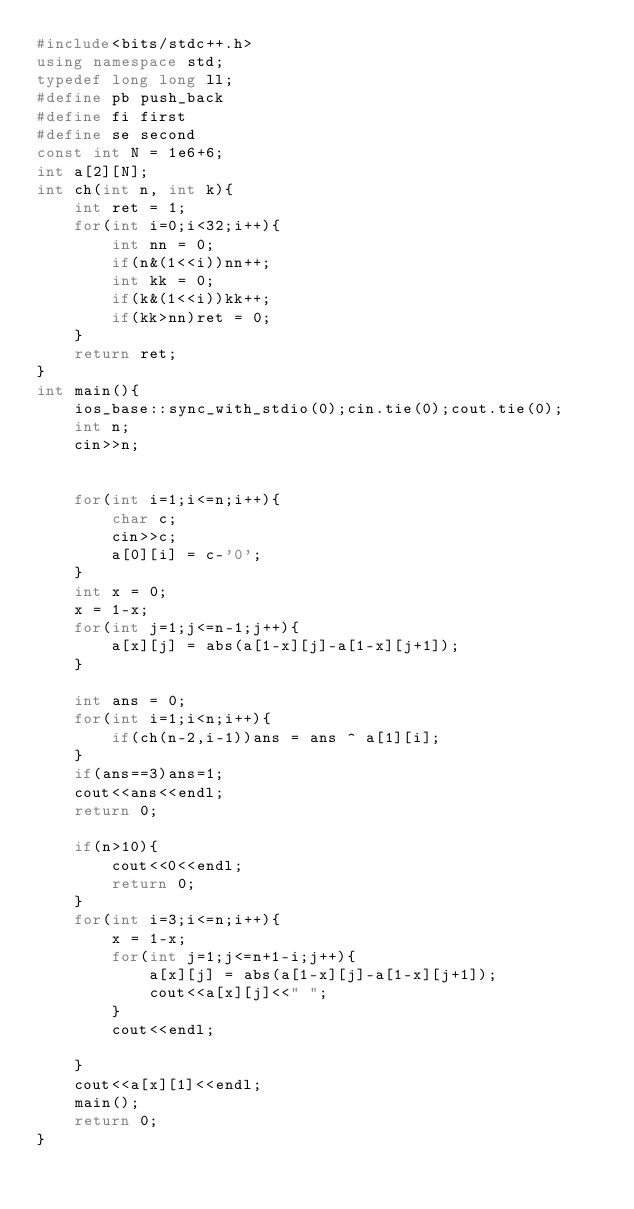Convert code to text. <code><loc_0><loc_0><loc_500><loc_500><_C++_>#include<bits/stdc++.h>
using namespace std; 
typedef long long ll;
#define pb push_back
#define fi first
#define se second 
const int N = 1e6+6;
int a[2][N];
int ch(int n, int k){
	int ret = 1;
	for(int i=0;i<32;i++){
		int nn = 0;
		if(n&(1<<i))nn++;
		int kk = 0;
		if(k&(1<<i))kk++;
		if(kk>nn)ret = 0;
	}
	return ret;
}
int main(){
	ios_base::sync_with_stdio(0);cin.tie(0);cout.tie(0);
	int n; 
	cin>>n; 


	for(int i=1;i<=n;i++){
		char c; 
		cin>>c;
		a[0][i] = c-'0';
	}
	int x = 0;
	x = 1-x;
	for(int j=1;j<=n-1;j++){
		a[x][j] = abs(a[1-x][j]-a[1-x][j+1]);
	}
	
	int ans = 0;
	for(int i=1;i<n;i++){
		if(ch(n-2,i-1))ans = ans ^ a[1][i];
	}
	if(ans==3)ans=1;
	cout<<ans<<endl;
	return 0;

	if(n>10){
		cout<<0<<endl;
		return 0;
	}
	for(int i=3;i<=n;i++){
		x = 1-x;
		for(int j=1;j<=n+1-i;j++){
			a[x][j] = abs(a[1-x][j]-a[1-x][j+1]);
			cout<<a[x][j]<<" ";
		}
		cout<<endl;
		
	}
	cout<<a[x][1]<<endl;
	main();
	return 0;
}
</code> 